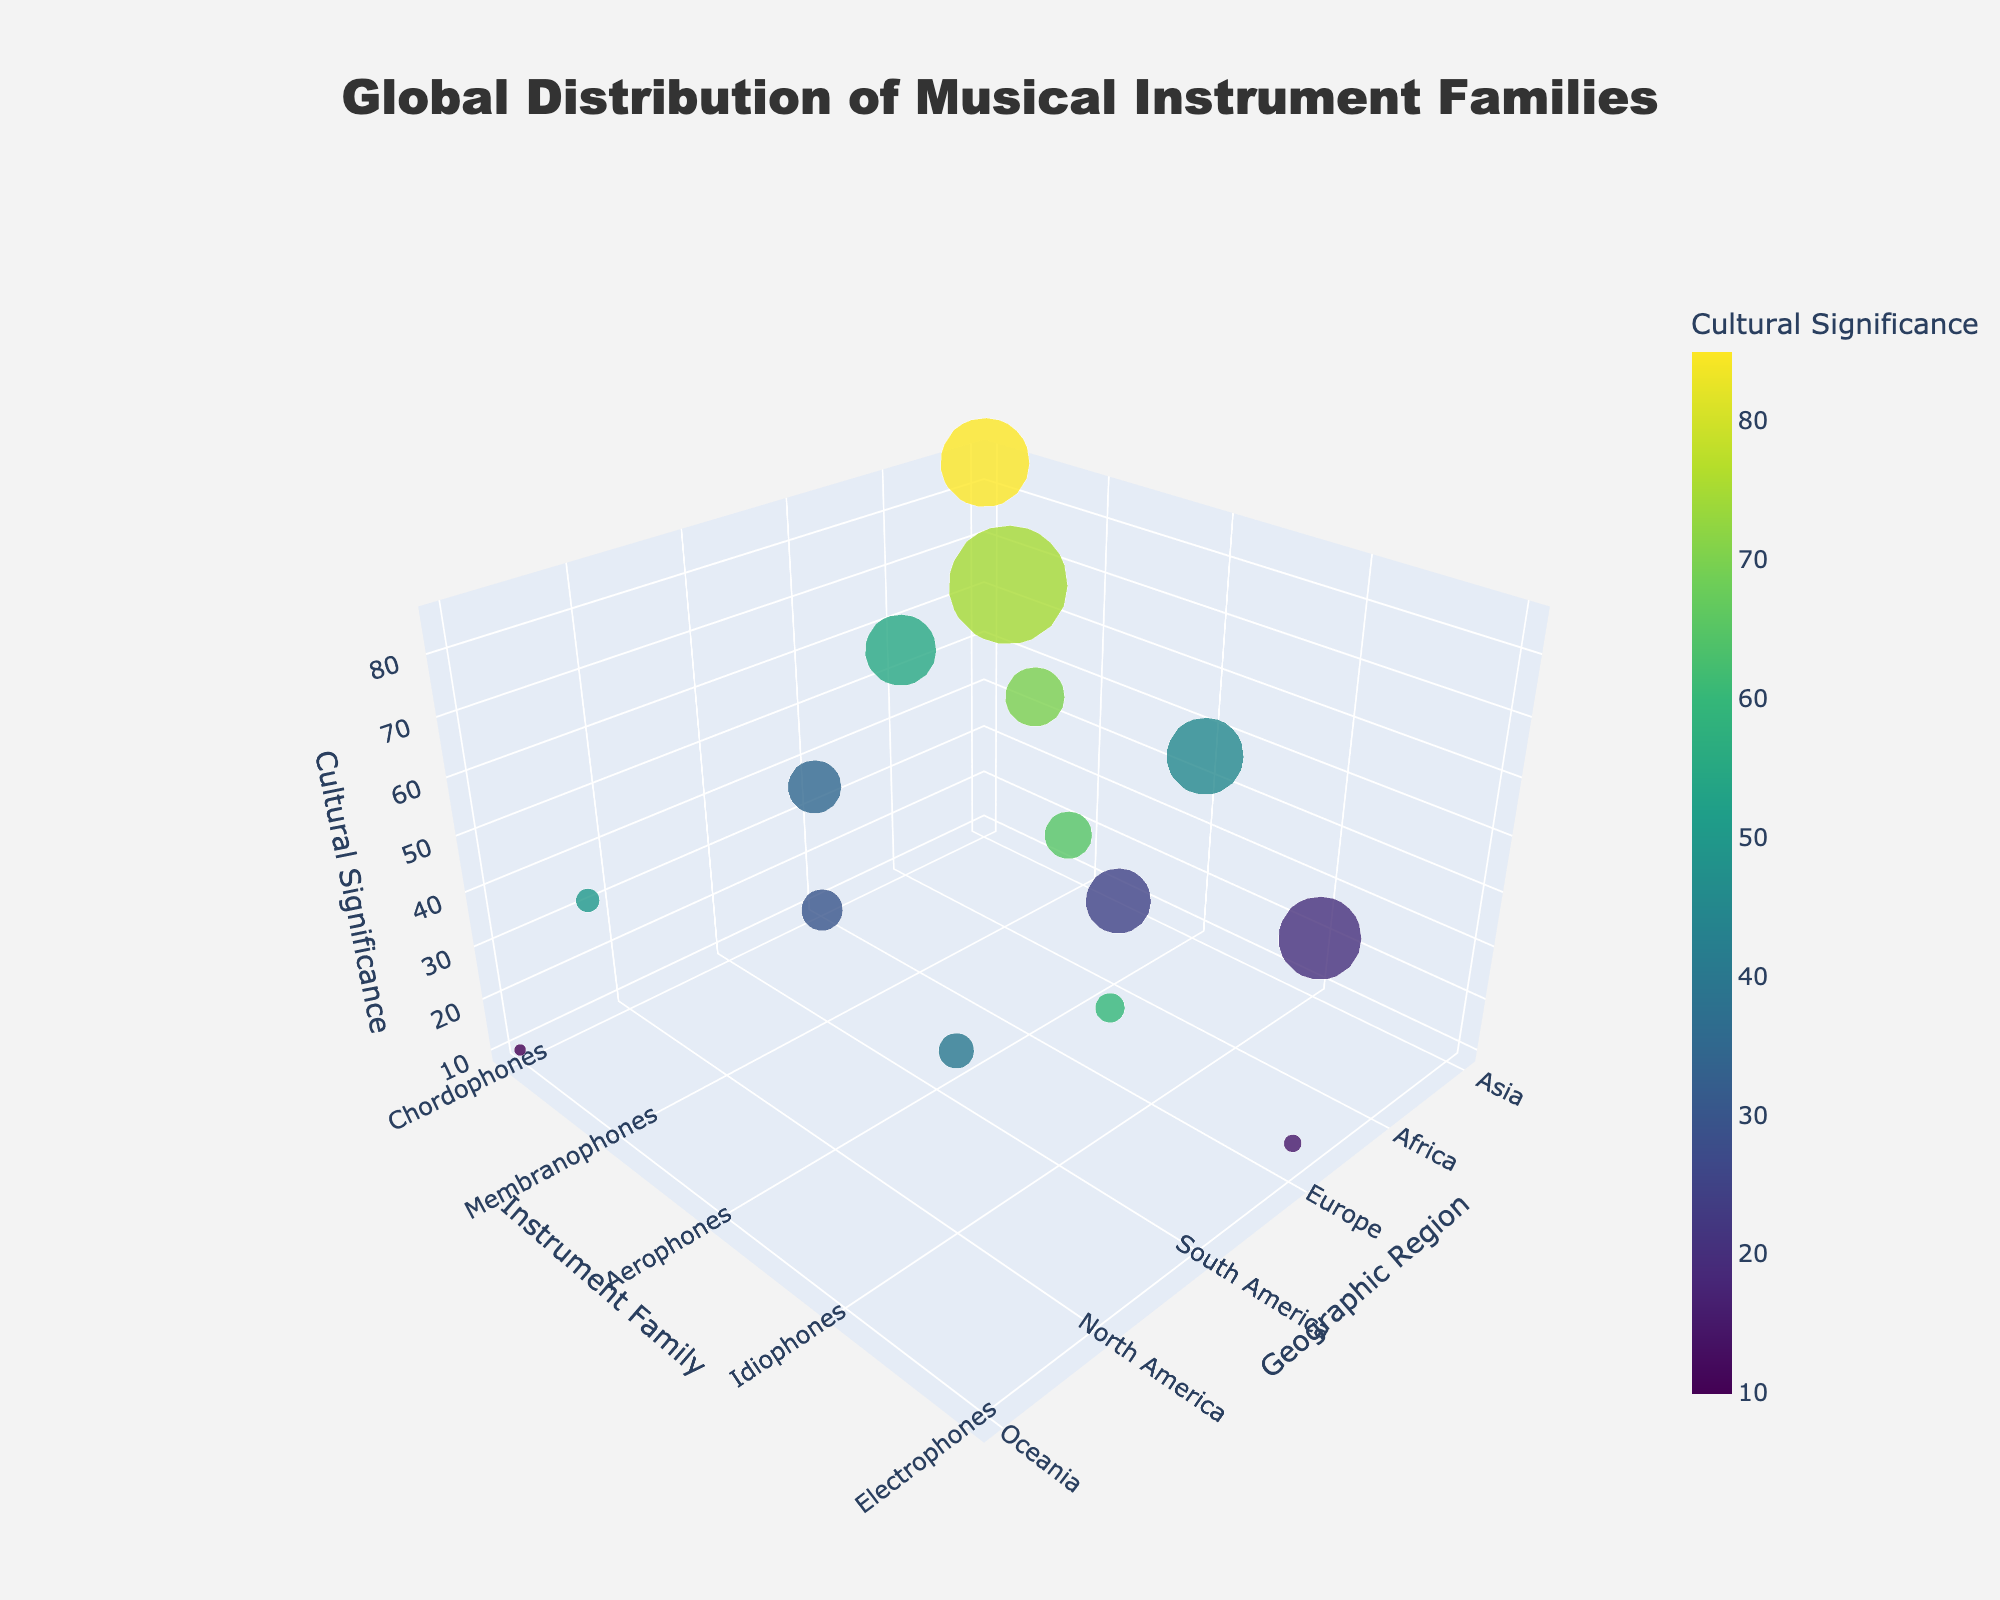What's the title of the figure? The title of the figure is located at the top and it usually summarizes the visual data representation.
Answer: Global Distribution of Musical Instrument Families Which instrument family has the highest cultural significance in Asia? Look for the bubbles in the "Asia" region, then find the one with the highest position along the "Cultural Significance" axis.
Answer: Chordophones How many data points represent the Membranophones family? Count all bubbles labeled as "Membranophones."
Answer: 3 Which geographical region has the smallest number of cultures represented in Electrophones? Find the bubbles labeled "Electrophones" and compare their sizes to determine the smallest one.
Answer: Europe What appears to be the approximate cultural significance of Idiophones in North America? Locate the "Idiophones" bubble in the "North America" region and check its position on the "Cultural Significance" axis.
Answer: 40 Compare the cultural significance of Chordophones in Europe and Africa. Which one is higher? Identify the bubbles for "Chordophones" in both "Europe" and "Africa" and compare their positions on the "Cultural Significance" axis. The one higher up has greater significance.
Answer: Africa What is the average number of cultures represented by Membranophones across all regions? Add the number of cultures for all Membranophones and divide by the number of Membranophones data points (75+200+50+30).
Answer: 88.75 What is the difference in cultural significance between Aerophones in Asia and Europe? Find the "Aerophones" bubbles in both "Asia" and "Europe". Subtract the "Cultural Significance" value of "Europe" from that of "Asia".
Answer: 25 Which instrument family has the most diverse geographic distribution, based on the number of regions it appears in? Count the regions for each instrument family by looking at their bubbles. The one with the highest count is the most diverse.
Answer: Chordophones Identify the instrument family and geographic region combination that has the highest number of cultures. Scan through the bubbles to find the one with the largest size. Check its instrument family and geographic region.
Answer: Membranophones in Africa 